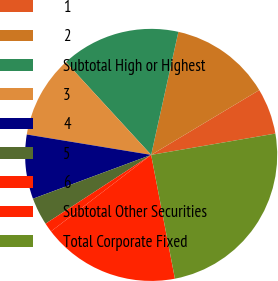<chart> <loc_0><loc_0><loc_500><loc_500><pie_chart><fcel>1<fcel>2<fcel>Subtotal High or Highest<fcel>3<fcel>4<fcel>5<fcel>6<fcel>Subtotal Other Securities<fcel>Total Corporate Fixed<nl><fcel>5.89%<fcel>12.94%<fcel>15.29%<fcel>10.59%<fcel>8.24%<fcel>3.54%<fcel>1.19%<fcel>17.64%<fcel>24.69%<nl></chart> 